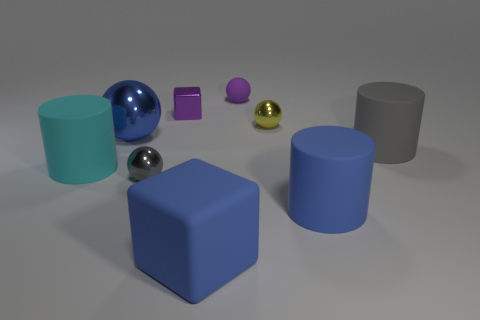What number of things are blue objects in front of the gray matte thing or spheres that are behind the small gray shiny ball?
Make the answer very short. 5. There is a tiny yellow metallic thing; are there any large blue metallic objects to the right of it?
Offer a terse response. No. How many things are big rubber objects on the right side of the large blue sphere or cyan cylinders?
Ensure brevity in your answer.  4. What number of blue things are large shiny balls or big cubes?
Keep it short and to the point. 2. How many other objects are there of the same color as the rubber block?
Make the answer very short. 2. Is the number of big matte cylinders to the right of the small yellow object less than the number of big cyan rubber spheres?
Provide a short and direct response. No. What is the color of the tiny metallic ball that is behind the small metallic ball left of the purple thing that is to the left of the matte cube?
Ensure brevity in your answer.  Yellow. Is there any other thing that has the same material as the big cube?
Provide a succinct answer. Yes. The blue matte object that is the same shape as the large cyan matte object is what size?
Offer a terse response. Large. Is the number of purple cubes that are right of the purple matte thing less than the number of large objects in front of the large blue cylinder?
Provide a short and direct response. Yes. 